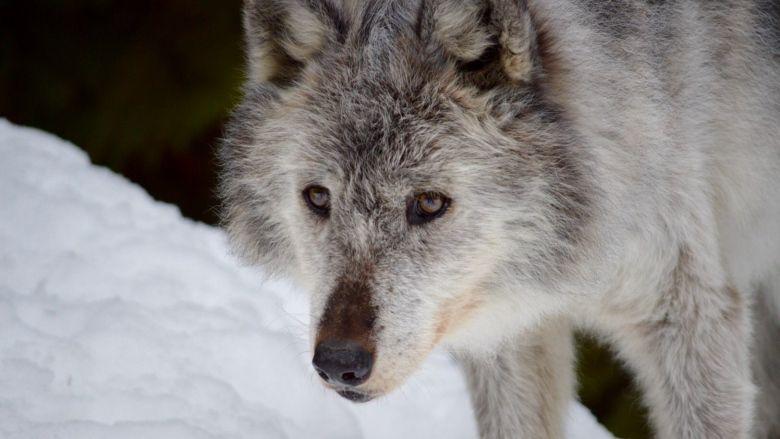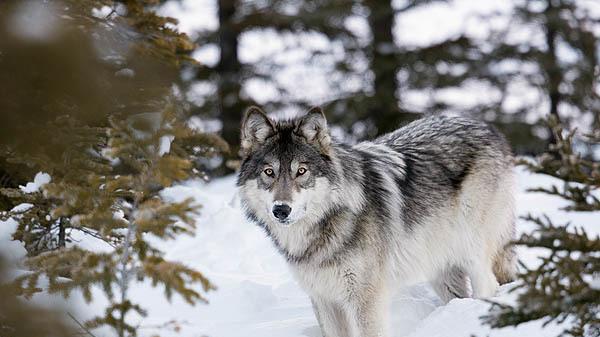The first image is the image on the left, the second image is the image on the right. Given the left and right images, does the statement "There are at least three canines." hold true? Answer yes or no. No. The first image is the image on the left, the second image is the image on the right. Considering the images on both sides, is "At least one of the wild dogs is laying down and none are in snow." valid? Answer yes or no. No. 